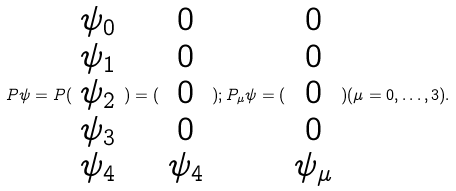Convert formula to latex. <formula><loc_0><loc_0><loc_500><loc_500>P \psi = P ( \begin{array} { c } \psi _ { 0 } \\ \psi _ { 1 } \\ \psi _ { 2 } \\ \psi _ { 3 } \\ \psi _ { 4 } \end{array} ) = ( \begin{array} { c } 0 \\ 0 \\ 0 \\ 0 \\ \psi _ { 4 } \end{array} ) ; P _ { \mu } \psi = ( \begin{array} { c } 0 \\ 0 \\ 0 \\ 0 \\ \psi _ { \mu } \end{array} ) ( \mu = 0 , \dots , 3 ) .</formula> 